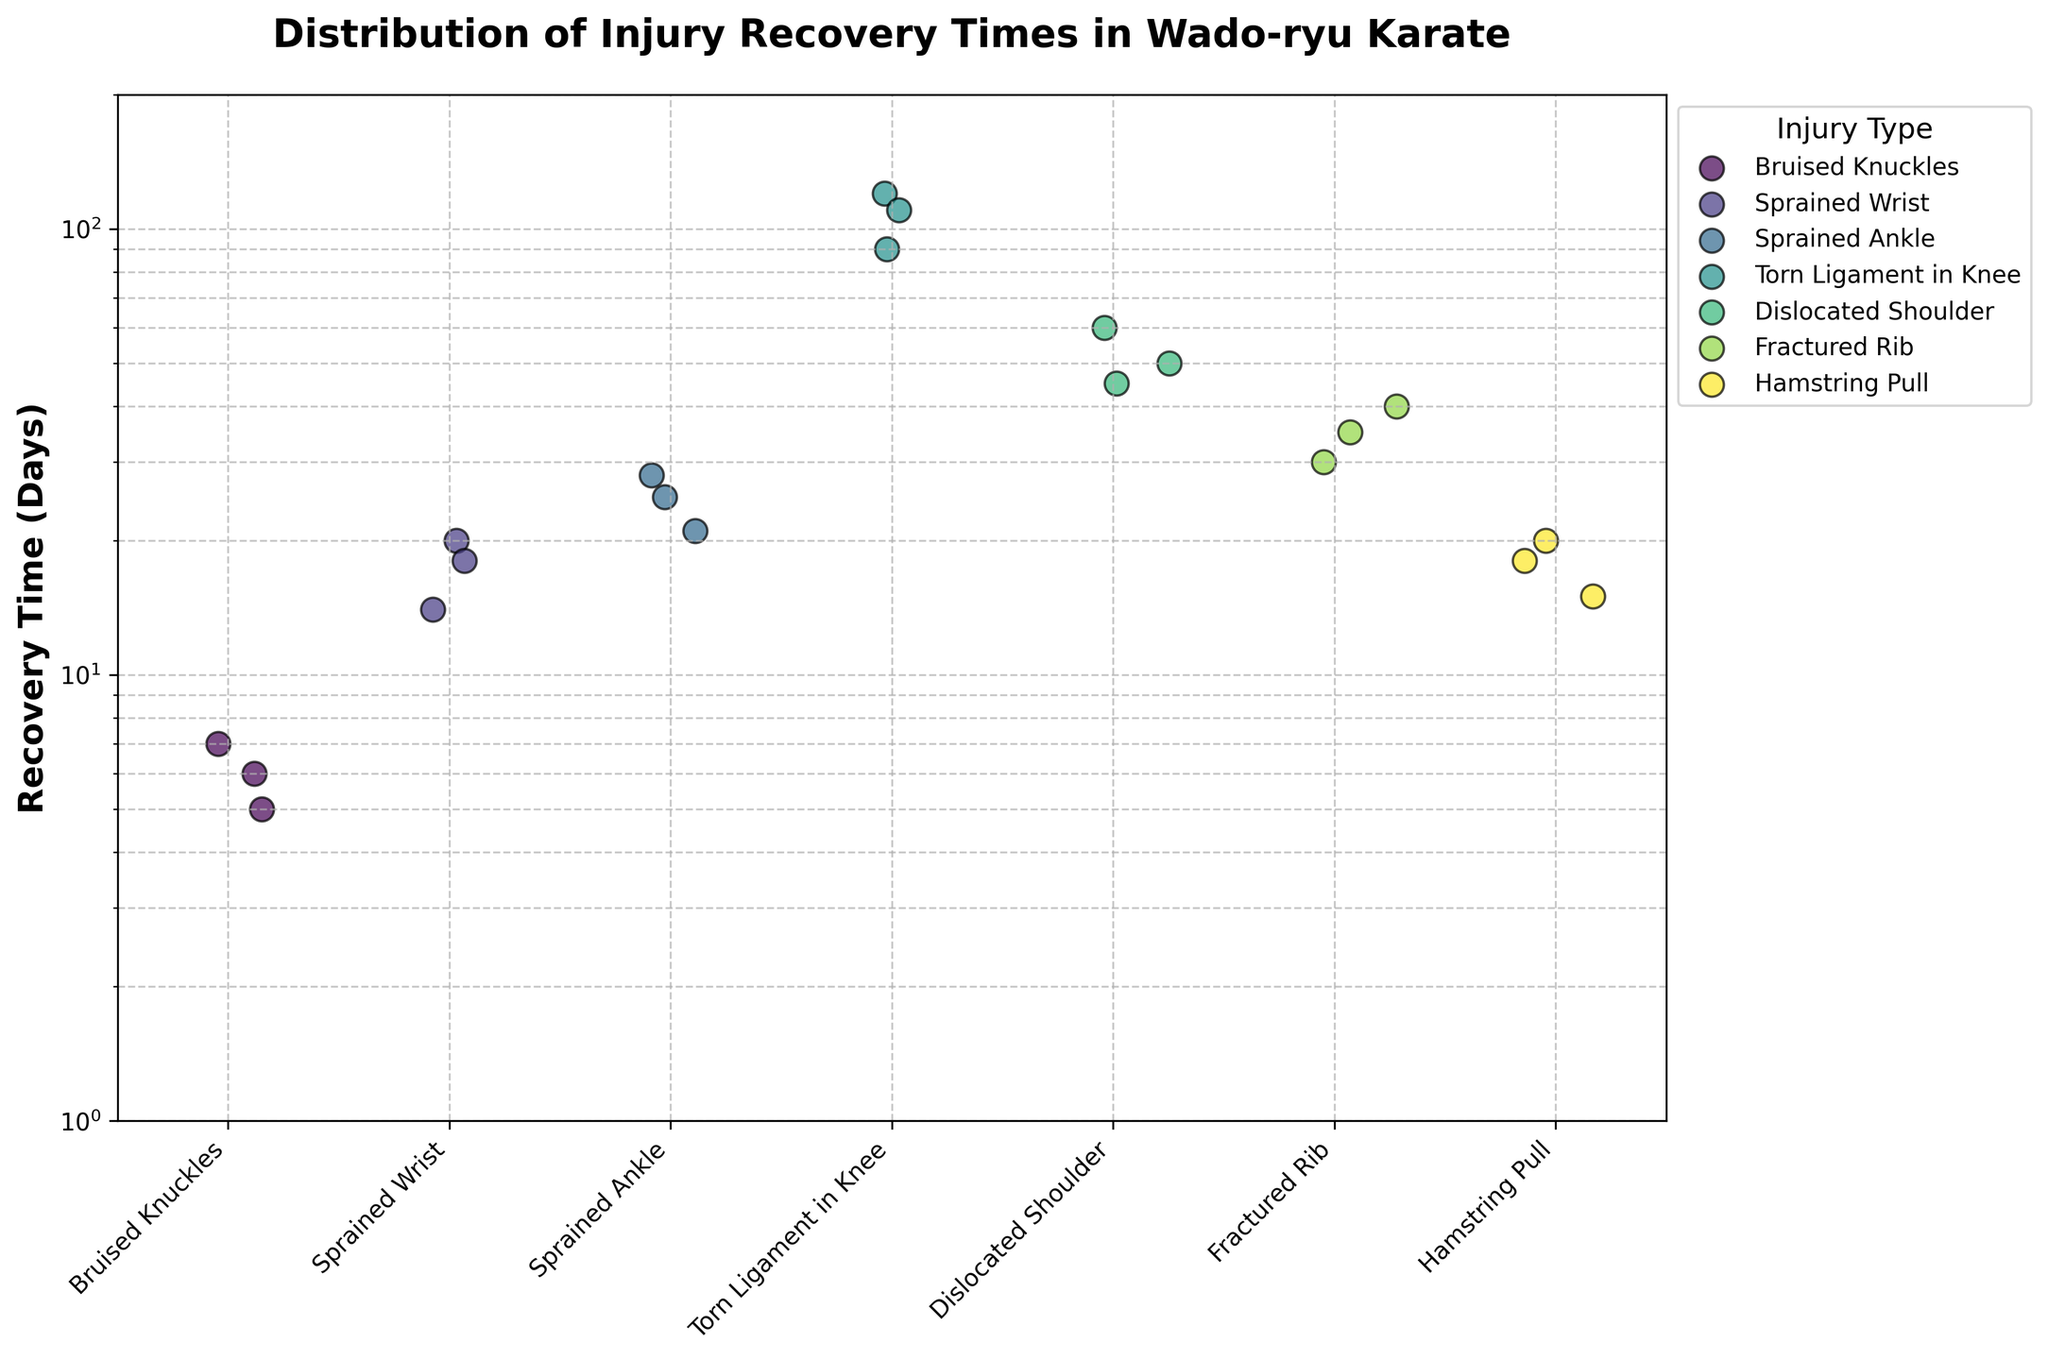what is the title of the plot? The title of the plot is written at the top of the figure. It states the broad theme of the visualization.
Answer: Distribution of Injury Recovery Times in Wado-ryu Karate which injury type has the longest median recovery time? To determine the median recovery time, sort the recovery times for each injury type and find the middle value. Torn Ligament in Knee has the median value of 110 days.
Answer: Torn Ligament in Knee what is the recovery time range for a hamstring pull? The recovery times for Hamstring Pull are plotted within the log-scaled y-axis. The recorded times are 15, 18, and 20 days. The range is the difference between the maximum and minimum time.
Answer: 5 days how many injury types are displayed in the plot? The plot has its x-axis labeled with each unique injury type. Count these labels to find the total number of injury types.
Answer: 7 how do the recovery times for bruised knuckles compare to fractured rib? Compare the spread of data points for Bruised Knuckles and Fractured Rib on the y-axis in log scale. The max and min values show Bruised Knuckles lie between 5–7 days, while Fractured Rib lies between 30–40 days.
Answer: Fractured Rib takes longer which injury has the widest range of recovery times? Observe the vertical spread of data points for each injury type. The injury type with the longest vertical spread indicates the widest range. Torn Ligament in Knee ranges from 90 to 120 days, the widest observed.
Answer: Torn Ligament in Knee how are the injuries distributed across the plot's x-axis? Each unique injury type is represented along the x-axis with spaced positioning. The arrangement helps to visually separate different injuries.
Answer: Evenly spaced how does the recovery time of dislocated shoulder generally compare to sprained wrist? Review the position of data points for Dislocated Shoulder and Sprained Wrist. Dislocated Shoulder ranges from 45–60 days, whereas Sprained Wrist ranges from 14–20 days. Generally, the former requires longer recovery.
Answer: Longer why use a log scale for the y-axis in this plot? Log scales help in visualizing skewed data, making it easier to compare recovery times spanning diverse magnitudes. For injuries with significant time differences, it clarifies small and large values well.
Answer: To visualize diverse time spans for which injury is the recovery time data most consistent? Consistency is inferred from how closely data points cluster together for an injury type. Observe Bruised Knuckles' points (5, 6, 7 days), which are very close to each other.
Answer: Bruised Knuckles 